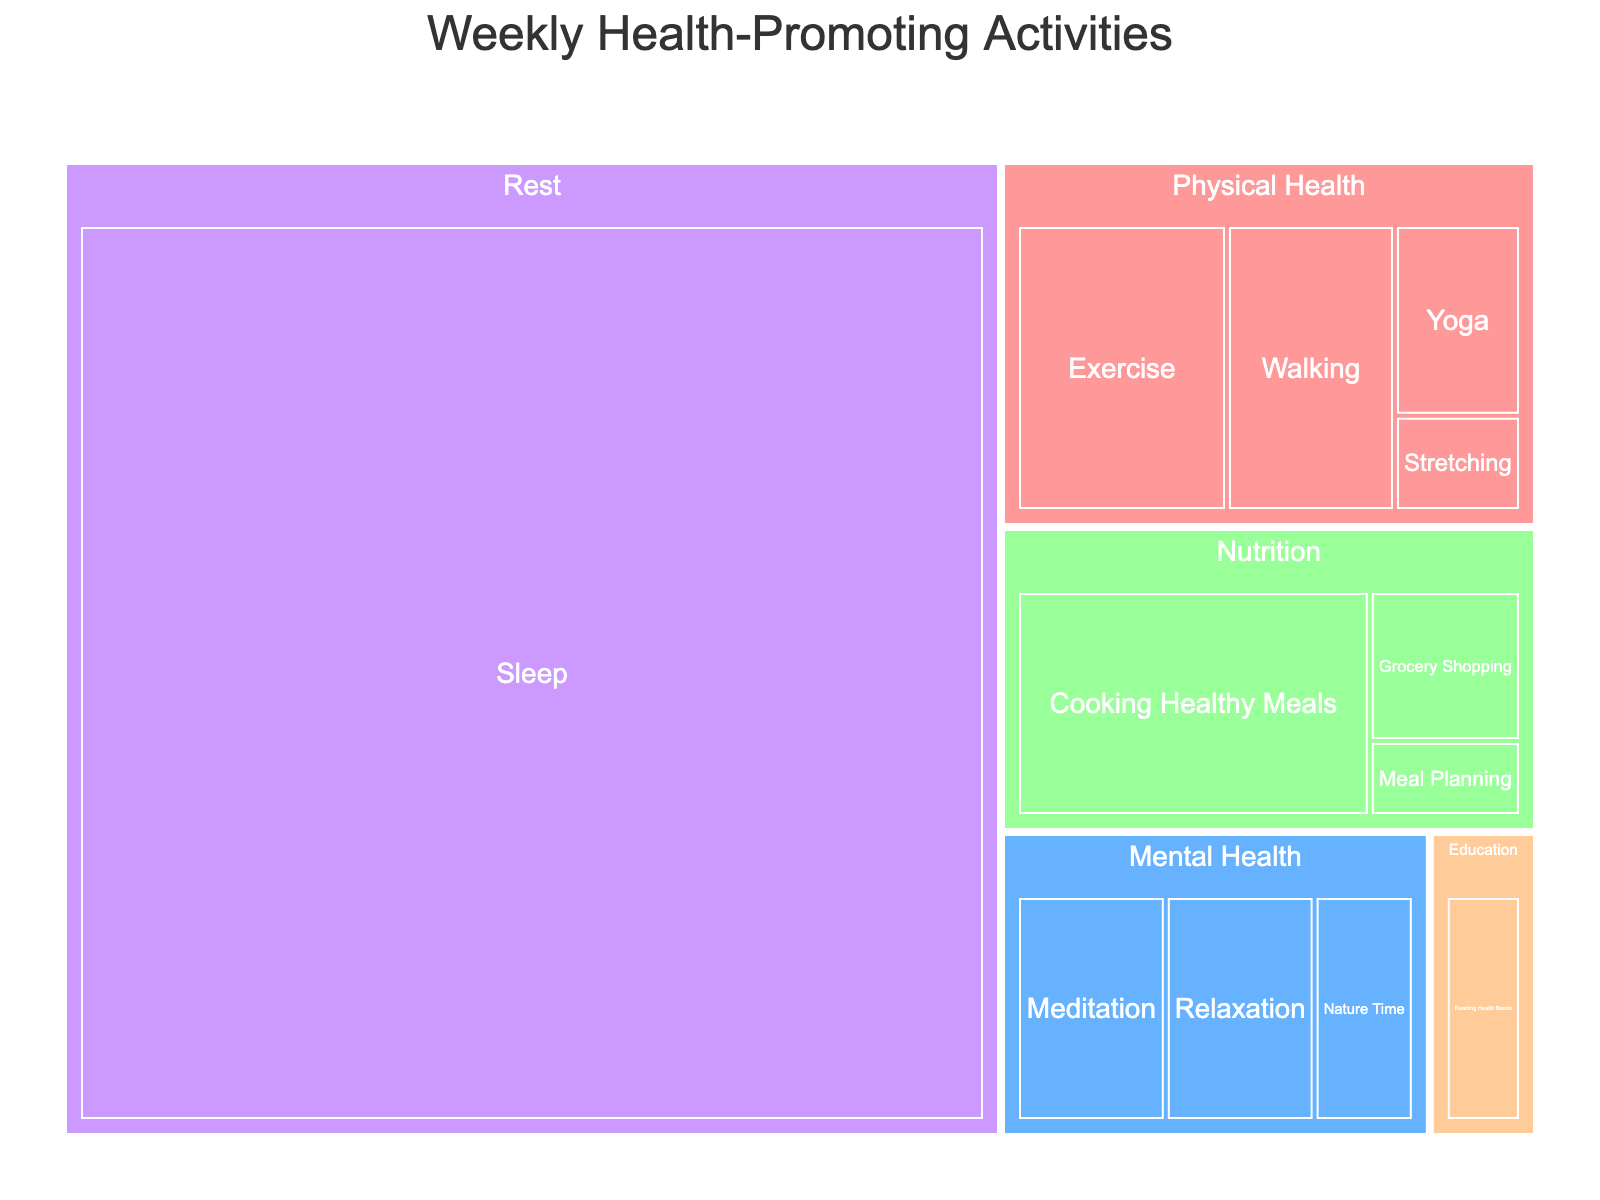How many hours are spent on Rest activities? Hover over the 'Rest' category in the treemap to check the total number of hours. The 'Rest' category specifically includes Sleep.
Answer: 56 Which category has the most hours dedicated to it? Compare the total hours for each category by looking at the size of their corresponding blocks in the treemap. The category with the largest block has the most hours.
Answer: Rest What activities fall under Physical Health, and how many hours are spent on each? Hover over the 'Physical Health' category to reveal sub-blocks and count the hours for each activity. Activities include Exercise (5), Yoga (2), Walking (4), and Stretching (1).
Answer: Exercise (5), Yoga (2), Walking (4), Stretching (1) Which activity related to Mental Health has the fewest hours, and what is its value? Look at the activities under the 'Mental Health' category and compare their sizes to find the smallest, which indicates the fewest hours. Nature Time has the fewest hours.
Answer: Nature Time (2) How many hours in total are spent on Nutrition activities? Sum the hours of all activities listed under the 'Nutrition' category. The activities are Cooking Healthy Meals (7), Grocery Shopping (2), and Meal Planning (1).
Answer: 10 Which activity is the largest single block in the treemap? Identify the single block that occupies the most space in the treemap, indicating the highest number of hours.
Answer: Sleep Compare the hours spent on Cooking Healthy Meals and Grocery Shopping. Which one has more hours, and by how much? Subtract the hours of Grocery Shopping from the hours of Cooking Healthy Meals. Cooking Healthy Meals has 7 hours and Grocery Shopping has 2, so (7-2 = 5).
Answer: Cooking Healthy Meals, by 5 hours What is the total time spent on both Physical Health and Education activities? Sum the hours of all activities under Physical Health and Education categories. Physical Health: (5+2+4+1) and Education: (2), so the total is (12+2).
Answer: 14 hours Which category uses a blue color in the treemap, and list its activities? Identify the category with a blue color by referring to the color legend. The 'Mental Health' category is blue, and its activities are Meditation (3), Relaxation (3), and Nature Time (2).
Answer: Mental Health: Meditation (3), Relaxation (3), Nature Time (2) Is more time spent on Exercise or on Meditation and Relaxation combined? Calculate the combined hours for Meditation and Relaxation and compare with Exercise. Meditation (3) + Relaxation (3) = 6, which is greater than Exercise (5).
Answer: Meditation and Relaxation combined (6) 